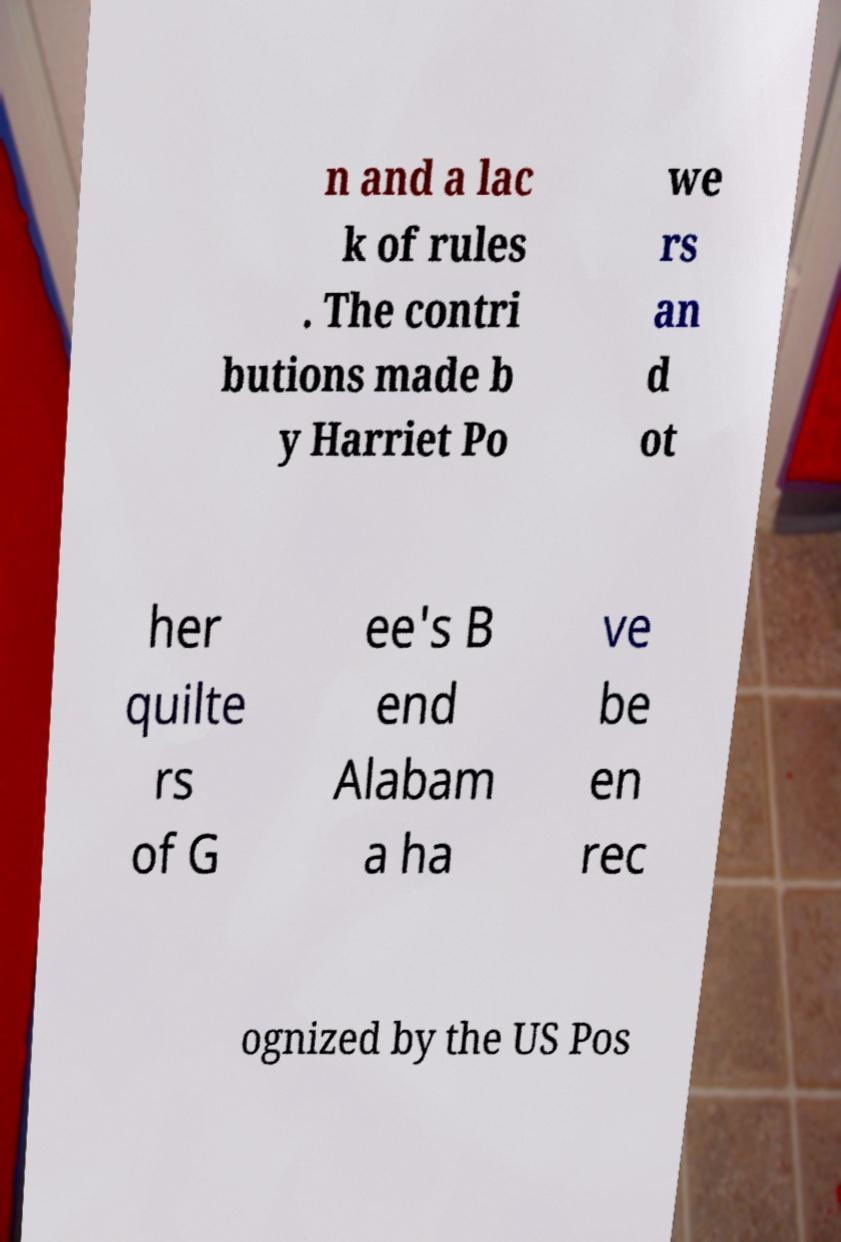Could you extract and type out the text from this image? n and a lac k of rules . The contri butions made b y Harriet Po we rs an d ot her quilte rs of G ee's B end Alabam a ha ve be en rec ognized by the US Pos 